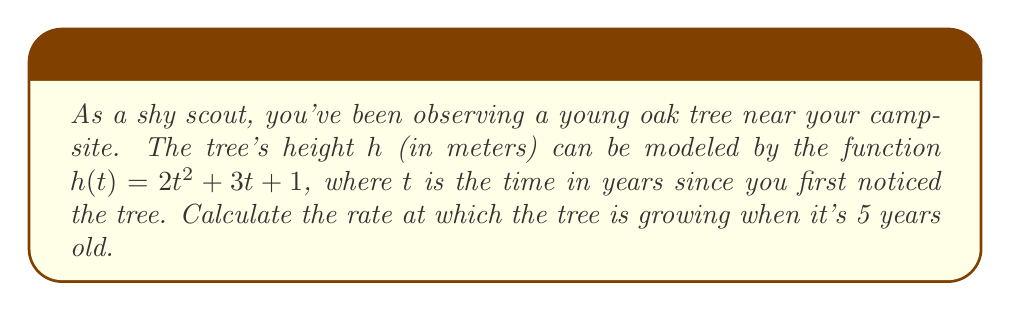Show me your answer to this math problem. To find the rate at which the tree is growing at a specific time, we need to calculate the derivative of the height function and evaluate it at the given time.

Step 1: Find the derivative of $h(t)$.
The height function is $h(t) = 2t^2 + 3t + 1$
Using the power rule and constant rule:
$$\frac{dh}{dt} = 4t + 3$$

Step 2: Evaluate the derivative at $t = 5$ years.
$$\frac{dh}{dt}\bigg|_{t=5} = 4(5) + 3 = 20 + 3 = 23$$

The rate of change is measured in meters per year, as height is in meters and time is in years.
Answer: 23 m/year 